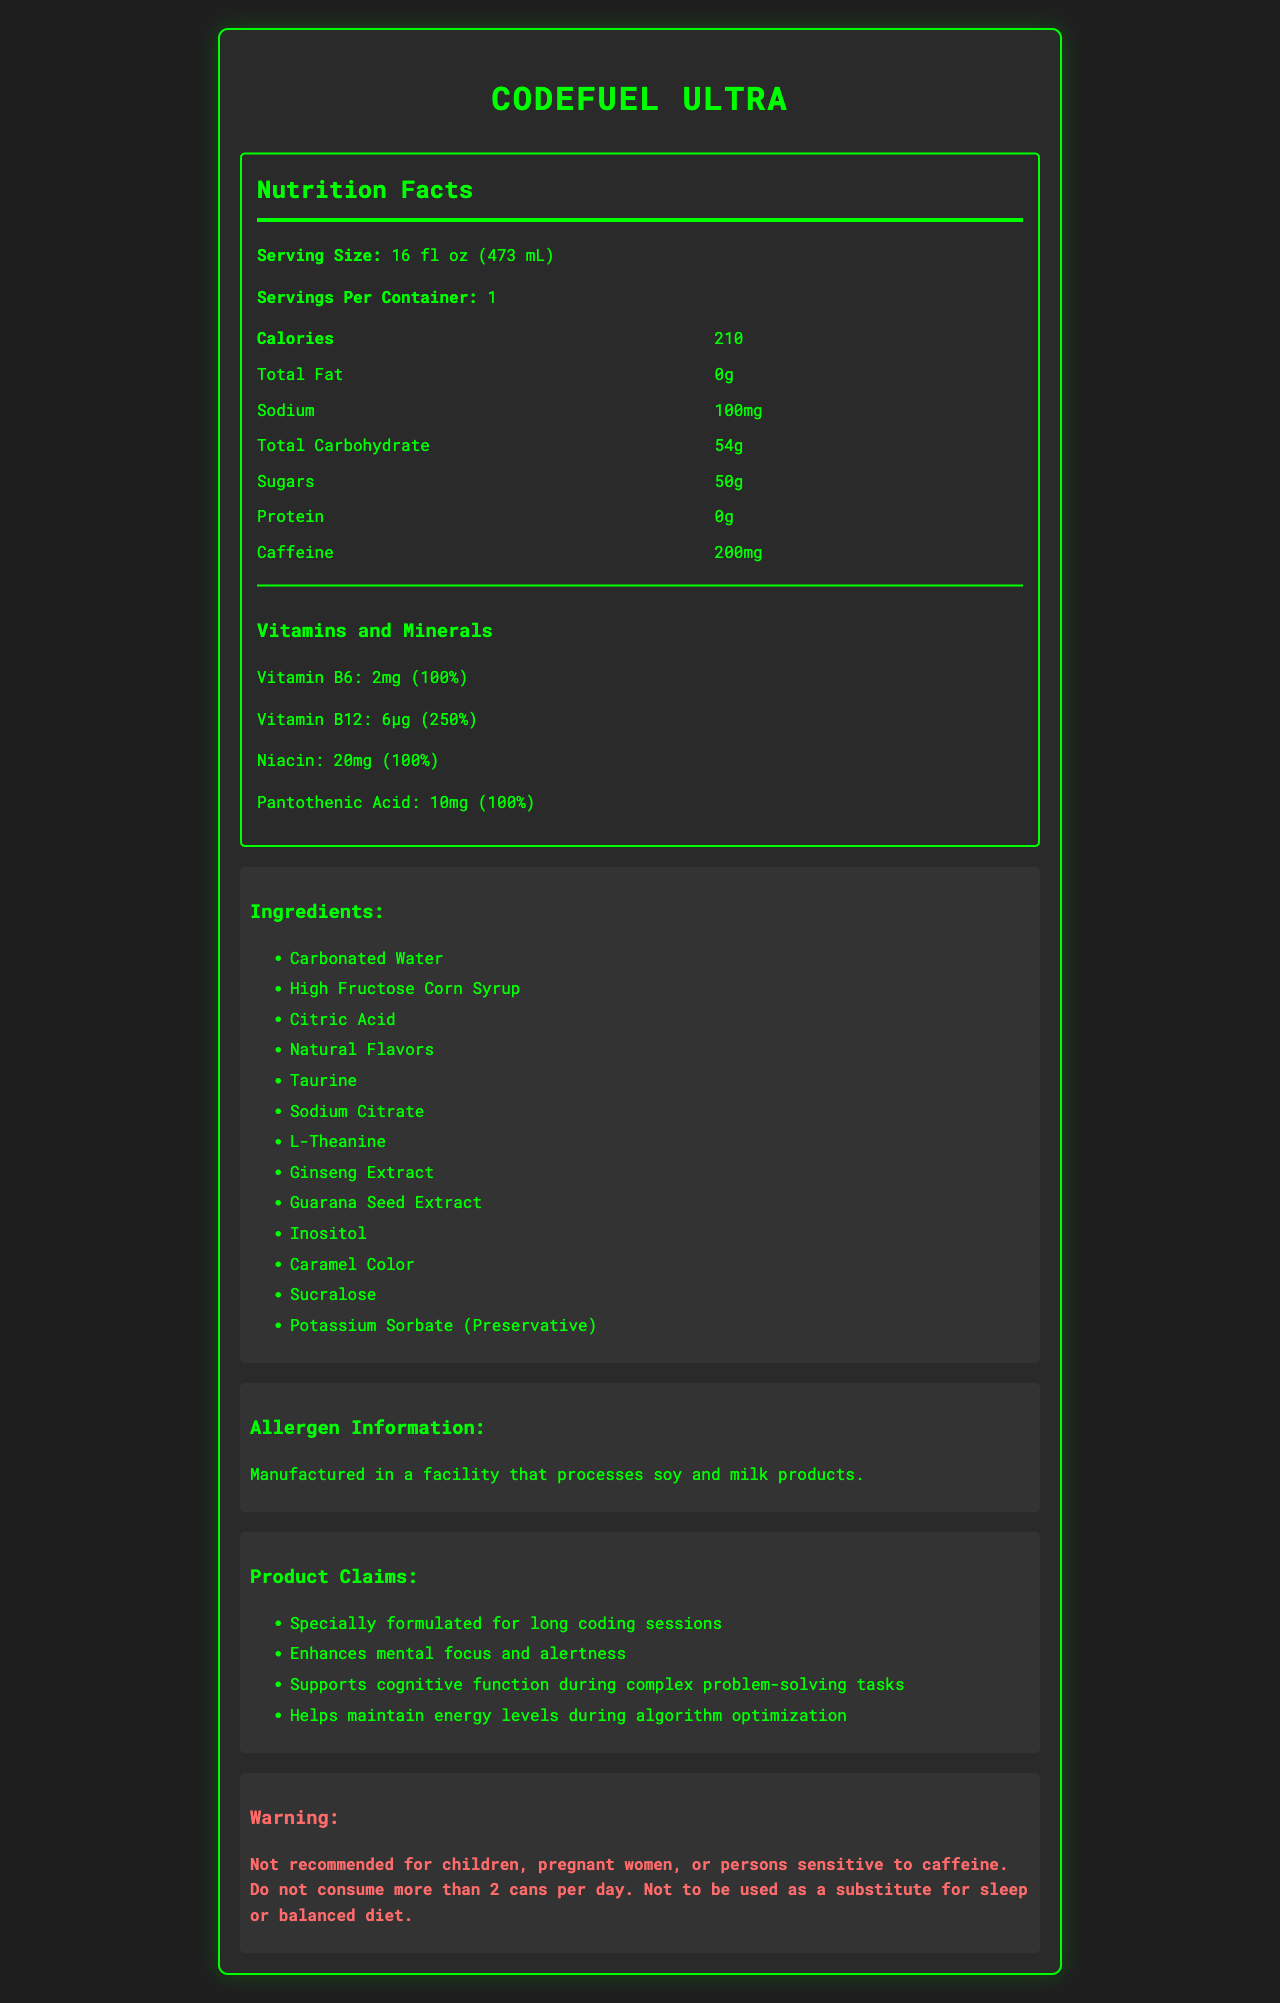what is the serving size for CodeFuel Ultra? The serving size is clearly stated at the beginning of the nutrition facts section.
Answer: 16 fl oz (473 mL) how many calories are in one serving of CodeFuel Ultra? The calories per serving are listed explicitly in the nutrition facts section.
Answer: 210 what is the total carbohydrate content in CodeFuel Ultra? The total carbohydrate content can be found in the nutrition facts section.
Answer: 54g how much caffeine does CodeFuel Ultra contain per serving? The caffeine content is listed in the nutrition facts section.
Answer: 200mg what are the allergens listed on the label? The allergen information is clearly mentioned towards the end of the label.
Answer: Manufactured in a facility that processes soy and milk products the total sugar content in CodeFuel Ultra indicates high sweetness. true or false? The label indicates 50g of sugars, which suggests high sweetness.
Answer: True how many vitamins and minerals are listed on CodeFuel Ultra's label, and what are they? The vitamins and minerals section lists four items with their amounts and daily values.
Answer: Four: Vitamin B6, Vitamin B12, Niacin, and Pantothenic Acid which of the following is not an ingredient in CodeFuel Ultra? A. Inositol B. Ascorbic Acid C. Taurine D. Citric Acid The list of ingredients includes Inositol, Taurine, and Citric Acid, but not Ascorbic Acid.
Answer: B based on the document, who should avoid consuming CodeFuel Ultra? The warning section advises against consumption by these groups.
Answer: Children, pregnant women, or persons sensitive to caffeine what is the daily value percentage of Vitamin B12 in CodeFuel Ultra? The daily value percentage for Vitamin B12 is specified in the vitamins and minerals section as 250%.
Answer: 250% which ingredient is the main source of calorie content in CodeFuel Ultra? Based on the list of ingredients and the high sugar content, High Fructose Corn Syrup is likely the main calorie source.
Answer: High Fructose Corn Syrup describe the main claims that CodeFuel Ultra makes about its benefits. These claims are listed under the product claims section, describing the benefits of CodeFuel Ultra.
Answer: Specially formulated for long coding sessions, enhances mental focus and alertness, supports cognitive function during complex problem-solving tasks, helps maintain energy levels during algorithm optimization what is the purpose of potassium sorbate in CodeFuel Ultra? The document mentions potassium sorbate as a preservative, but does not provide specific details on its purpose.
Answer: Not enough information summarize the nutritional profile of CodeFuel Ultra. The summary covers key aspects of the drink's nutrition, ingredients, benefits, and safety information as presented in the document.
Answer: CodeFuel Ultra is an energy drink designed for computer programmers, containing 210 calories per serving, 0g of fat, 100mg of sodium, 54g of carbohydrates (50g of sugars), 0g of protein, and 200mg of caffeine. It also provides 100% of the daily values for Vitamin B6, Niacin, and Pantothenic Acid, and 250% for Vitamin B12. The drink includes various additives and is manufactured in a facility that processes soy and milk products. It claims to enhance mental focus, support cognitive function, and maintain energy during long coding sessions. A warning advises that it is not suitable for children, pregnant women, or those sensitive to caffeine. 